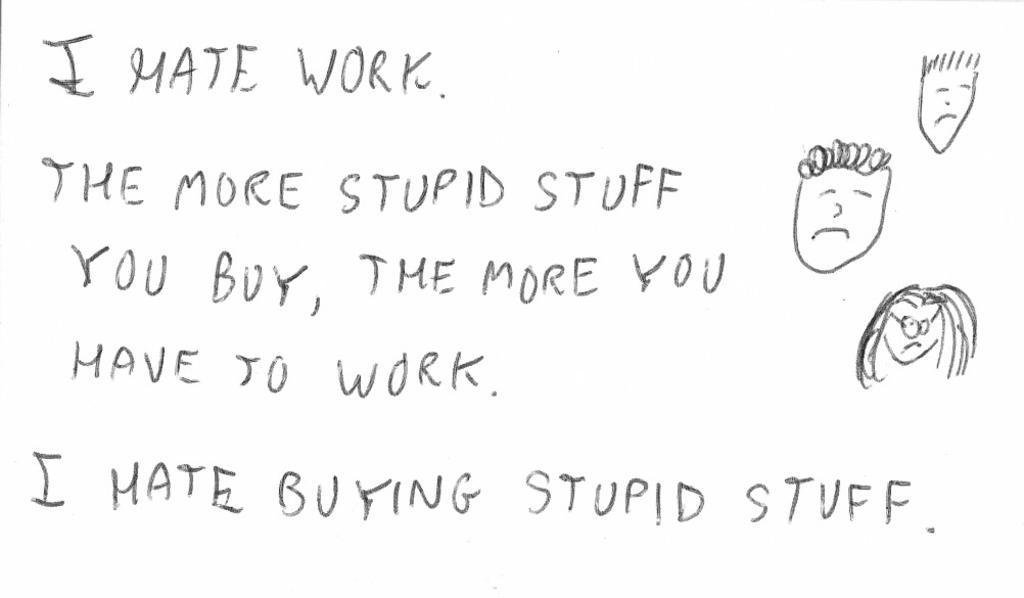Describe this image in one or two sentences. In this image we can see one poster with text and drawing images. 